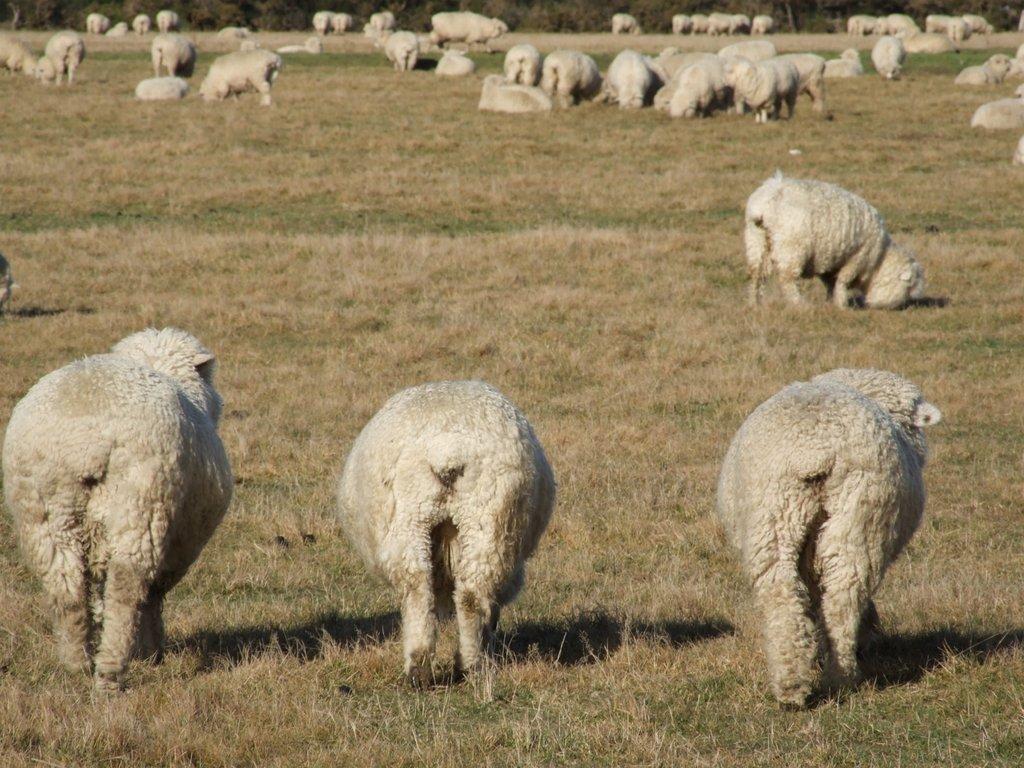How would you summarize this image in a sentence or two? There are animals standing on the ground. In the background there are animals standing and sitting on the ground and we can see trees. 